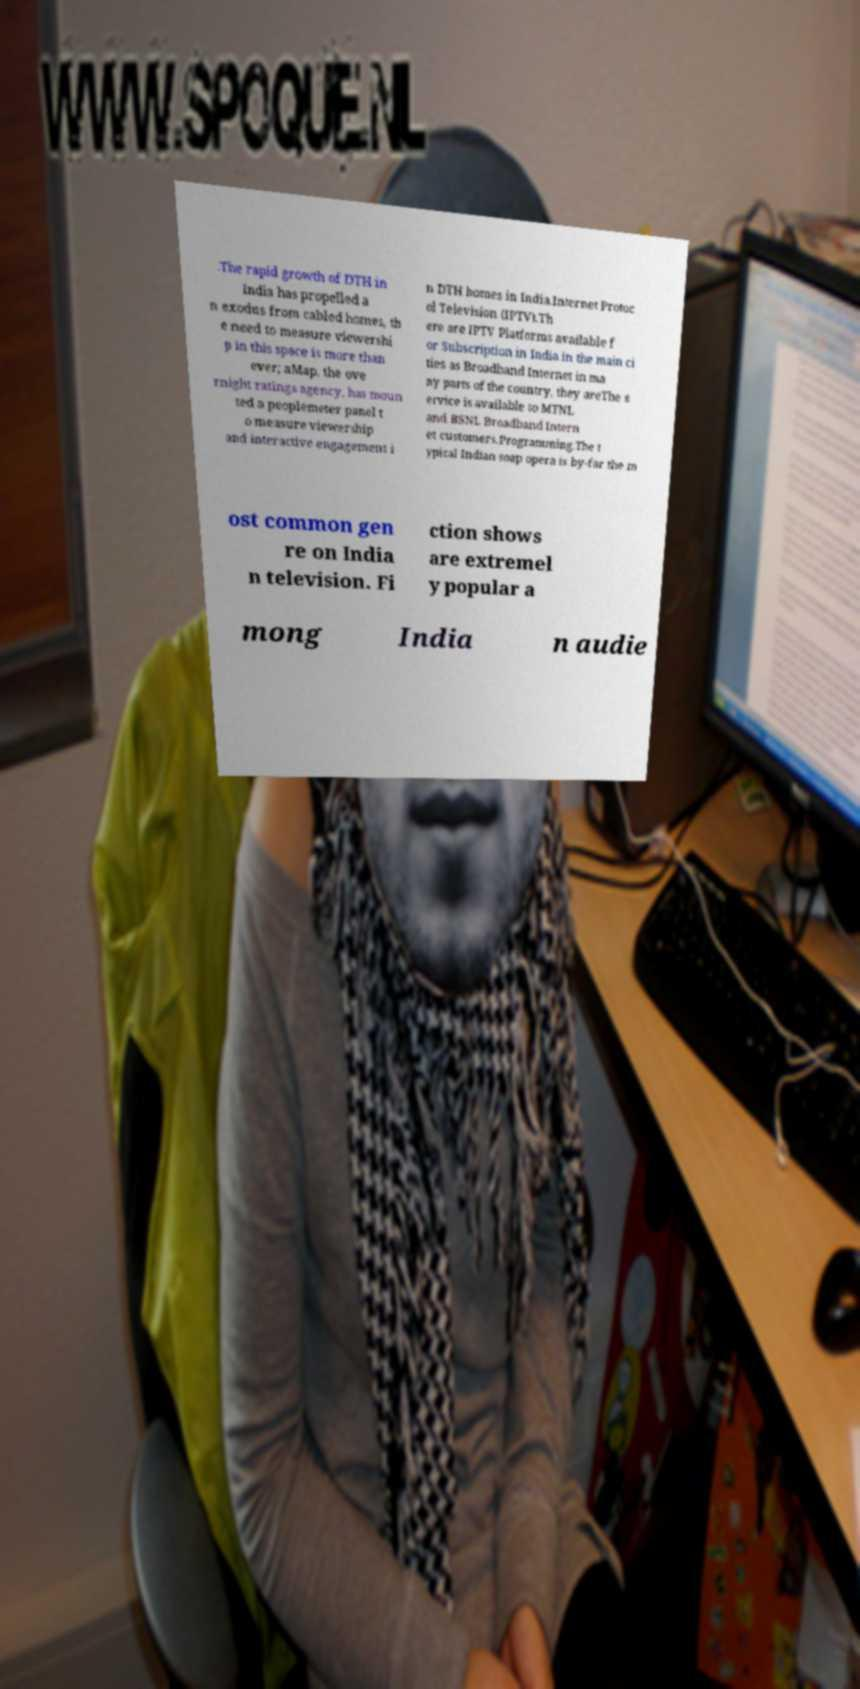Can you read and provide the text displayed in the image?This photo seems to have some interesting text. Can you extract and type it out for me? .The rapid growth of DTH in India has propelled a n exodus from cabled homes, th e need to measure viewershi p in this space is more than ever; aMap, the ove rnight ratings agency, has moun ted a peoplemeter panel t o measure viewership and interactive engagement i n DTH homes in India.Internet Protoc ol Television (IPTV).Th ere are IPTV Platforms available f or Subscription in India in the main ci ties as Broadband Internet in ma ny parts of the country, they areThe s ervice is available to MTNL and BSNL Broadband Intern et customers.Programming.The t ypical Indian soap opera is by-far the m ost common gen re on India n television. Fi ction shows are extremel y popular a mong India n audie 